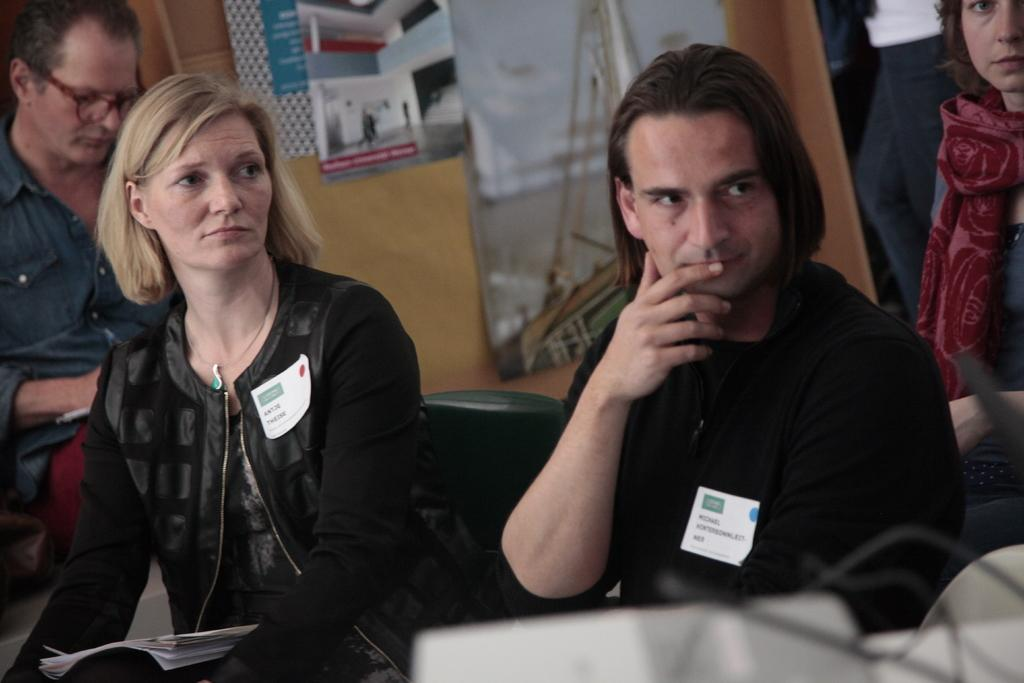What are the people in the image doing? The people in the image are sitting. What can be seen on the wall in the background of the image? There are boards placed on the wall in the background of the image. What type of plate is being used to serve the example in the image? There is no plate or example present in the image. What type of store is visible in the background of the image? There is no store visible in the image; it only shows people sitting and boards on the wall. 